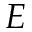Convert formula to latex. <formula><loc_0><loc_0><loc_500><loc_500>E</formula> 